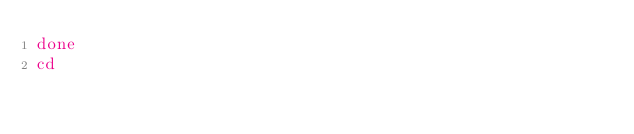Convert code to text. <code><loc_0><loc_0><loc_500><loc_500><_Bash_>done
cd
</code> 